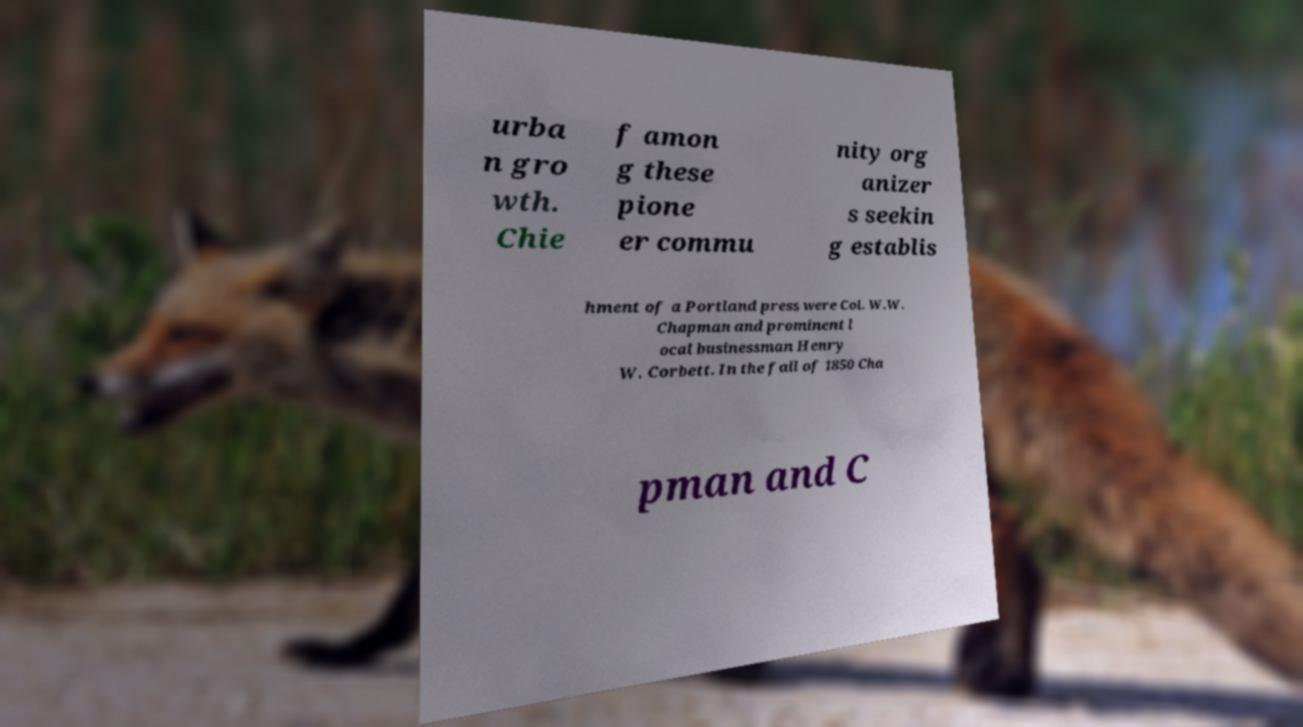I need the written content from this picture converted into text. Can you do that? urba n gro wth. Chie f amon g these pione er commu nity org anizer s seekin g establis hment of a Portland press were Col. W.W. Chapman and prominent l ocal businessman Henry W. Corbett. In the fall of 1850 Cha pman and C 